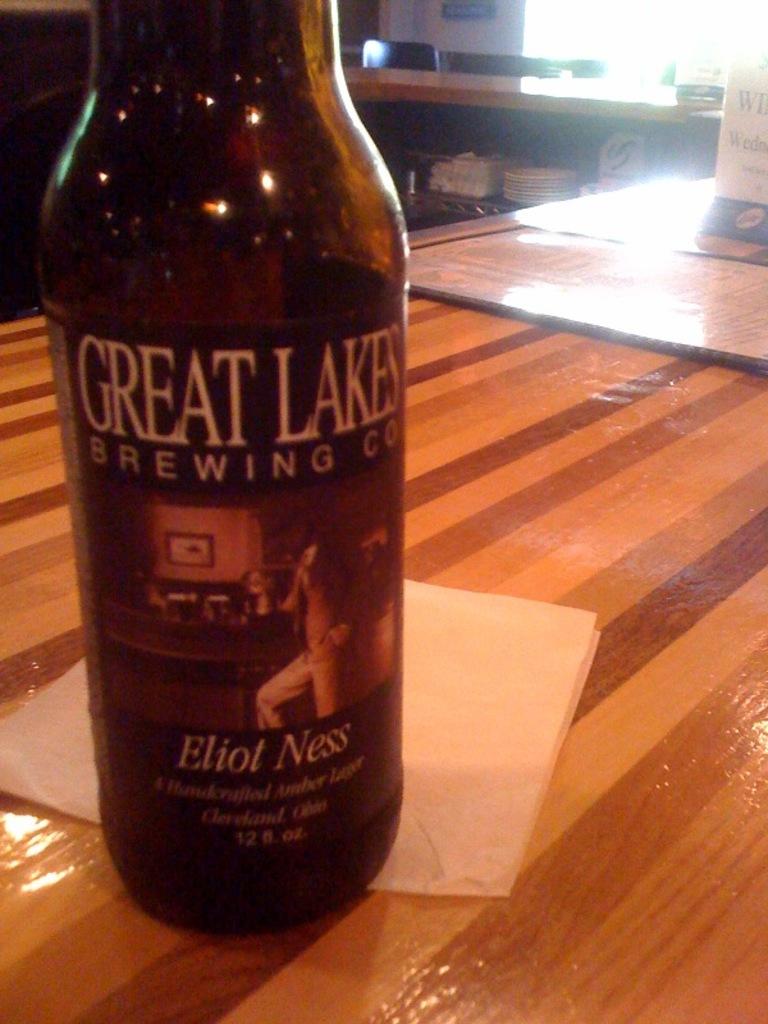What is that beer called?
Give a very brief answer. Eliot ness. What name is shown on this bottle?
Offer a terse response. Eliot ness. 